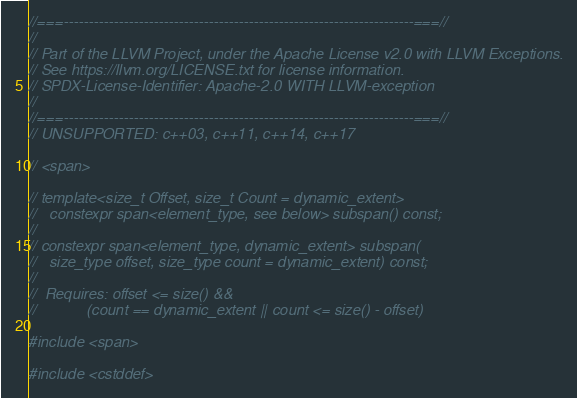<code> <loc_0><loc_0><loc_500><loc_500><_C++_>//===----------------------------------------------------------------------===//
//
// Part of the LLVM Project, under the Apache License v2.0 with LLVM Exceptions.
// See https://llvm.org/LICENSE.txt for license information.
// SPDX-License-Identifier: Apache-2.0 WITH LLVM-exception
//
//===----------------------------------------------------------------------===//
// UNSUPPORTED: c++03, c++11, c++14, c++17

// <span>

// template<size_t Offset, size_t Count = dynamic_extent>
//   constexpr span<element_type, see below> subspan() const;
//
// constexpr span<element_type, dynamic_extent> subspan(
//   size_type offset, size_type count = dynamic_extent) const;
//
//  Requires: offset <= size() &&
//            (count == dynamic_extent || count <= size() - offset)

#include <span>

#include <cstddef>
</code> 